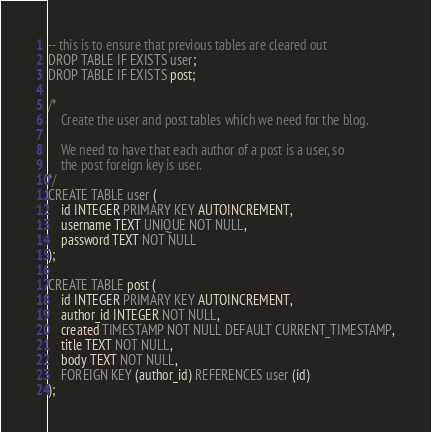Convert code to text. <code><loc_0><loc_0><loc_500><loc_500><_SQL_>
-- this is to ensure that previous tables are cleared out
DROP TABLE IF EXISTS user;
DROP TABLE IF EXISTS post;

/* 
	Create the user and post tables which we need for the blog. 

	We need to have that each author of a post is a user, so  
	the post foreign key is user. 
*/
CREATE TABLE user (
	id INTEGER PRIMARY KEY AUTOINCREMENT,
	username TEXT UNIQUE NOT NULL,
	password TEXT NOT NULL
);

CREATE TABLE post (
	id INTEGER PRIMARY KEY AUTOINCREMENT,
	author_id INTEGER NOT NULL,
	created TIMESTAMP NOT NULL DEFAULT CURRENT_TIMESTAMP,
	title TEXT NOT NULL,
	body TEXT NOT NULL,
	FOREIGN KEY (author_id) REFERENCES user (id)
);
</code> 